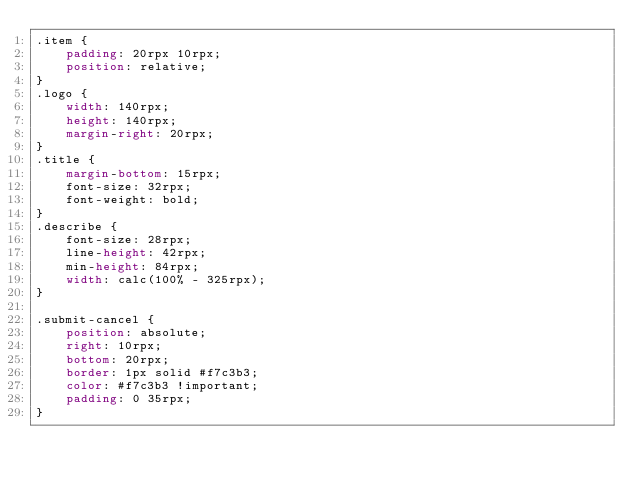<code> <loc_0><loc_0><loc_500><loc_500><_CSS_>.item {
    padding: 20rpx 10rpx;
    position: relative;
}
.logo {
    width: 140rpx;
    height: 140rpx;
    margin-right: 20rpx;
}
.title {
    margin-bottom: 15rpx;
    font-size: 32rpx;
    font-weight: bold;
}
.describe {
    font-size: 28rpx;
    line-height: 42rpx;
    min-height: 84rpx;
    width: calc(100% - 325rpx);
}

.submit-cancel {
    position: absolute;
    right: 10rpx;
    bottom: 20rpx;
    border: 1px solid #f7c3b3;
    color: #f7c3b3 !important;
    padding: 0 35rpx;
}</code> 